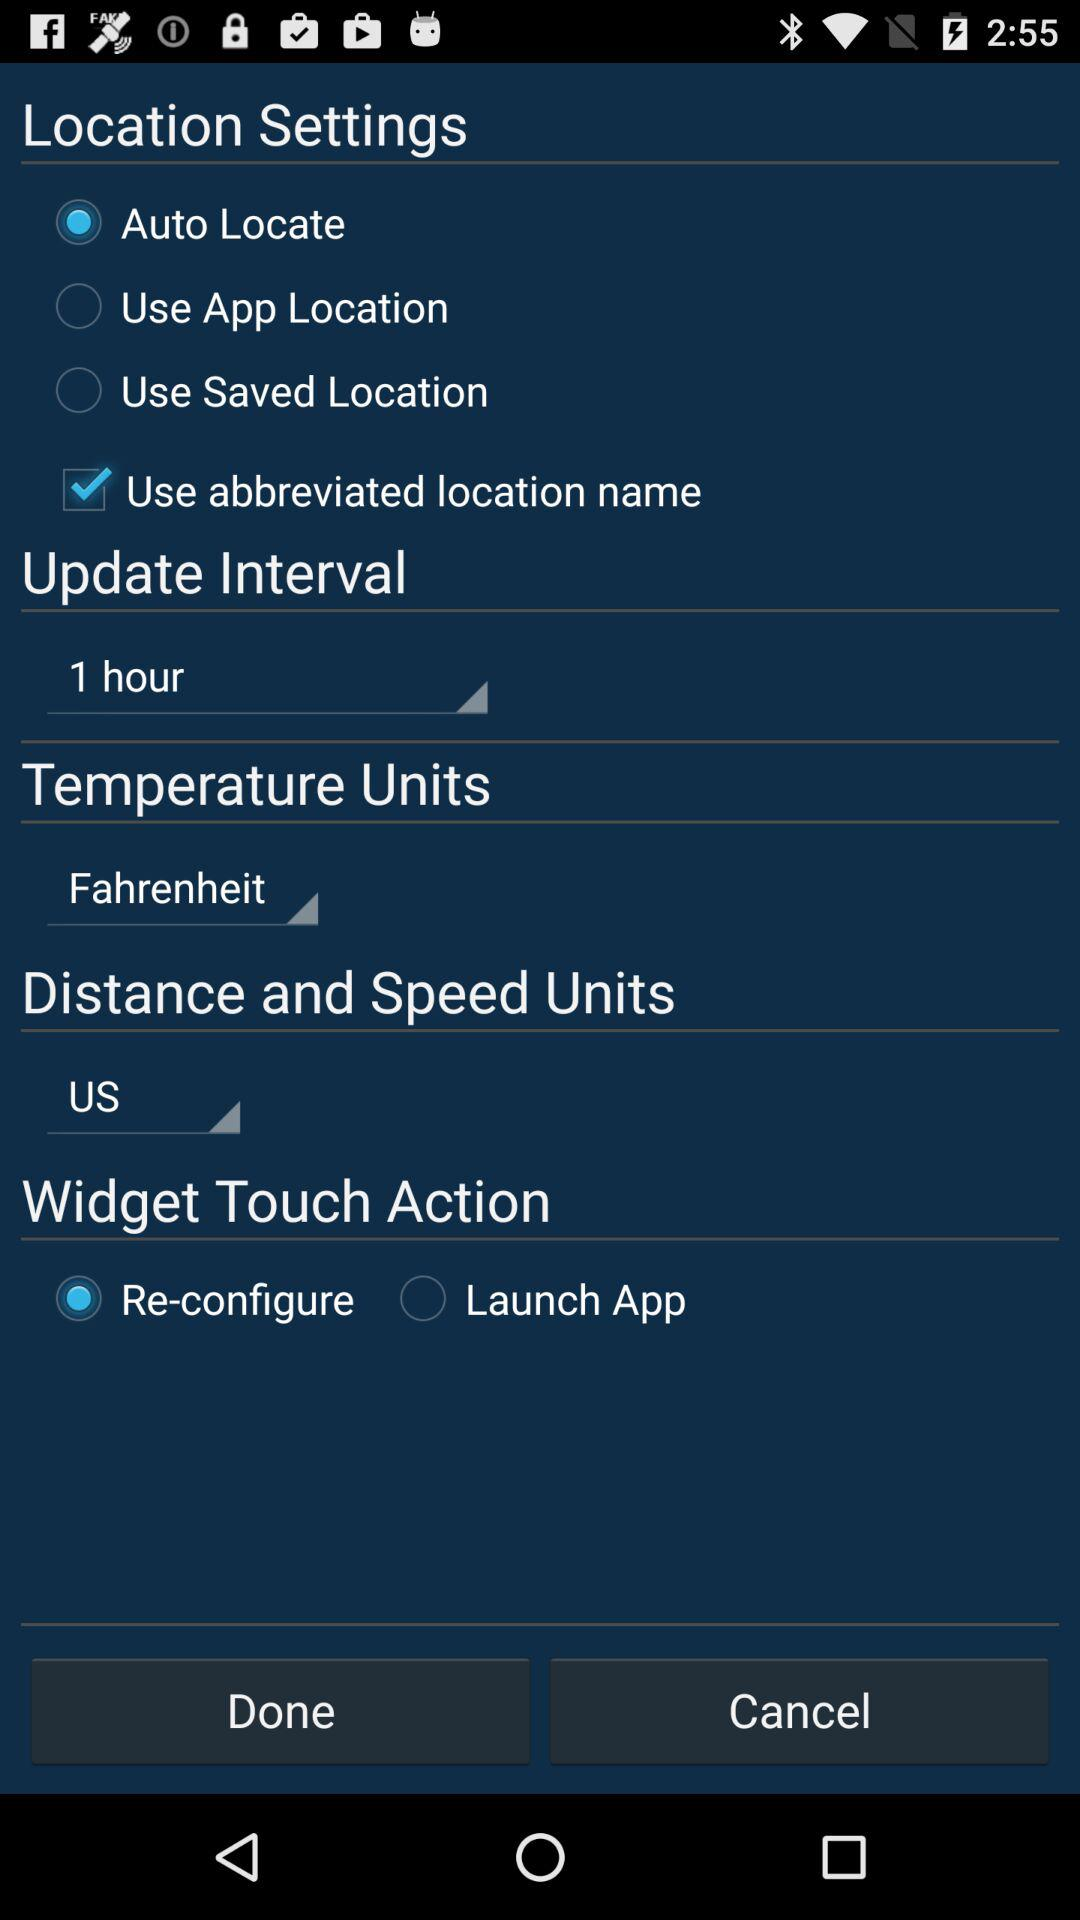What is distance and speed units? Distance and speed units is US. 